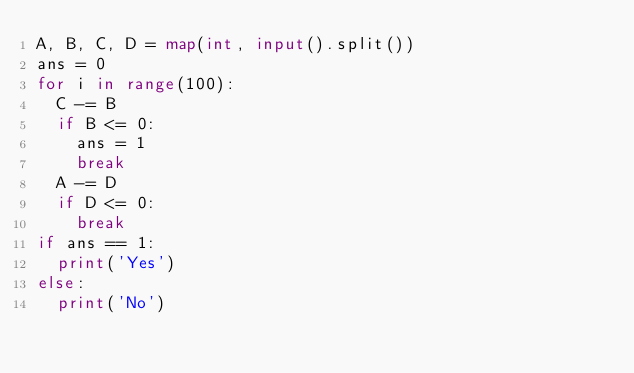Convert code to text. <code><loc_0><loc_0><loc_500><loc_500><_Python_>A, B, C, D = map(int, input().split())
ans = 0
for i in range(100):
  C -= B
  if B <= 0:
    ans = 1
    break
  A -= D
  if D <= 0:
    break
if ans == 1:
  print('Yes')
else:
  print('No')</code> 